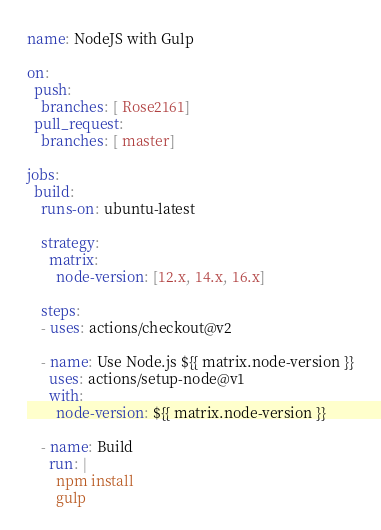<code> <loc_0><loc_0><loc_500><loc_500><_YAML_>name: NodeJS with Gulp

on:
  push:
    branches: [ Rose2161]
  pull_request:
    branches: [ master]

jobs:
  build:
    runs-on: ubuntu-latest

    strategy:
      matrix:
        node-version: [12.x, 14.x, 16.x]
    
    steps:
    - uses: actions/checkout@v2

    - name: Use Node.js ${{ matrix.node-version }}
      uses: actions/setup-node@v1
      with:
        node-version: ${{ matrix.node-version }}

    - name: Build
      run: |
        npm install
        gulp
</code> 